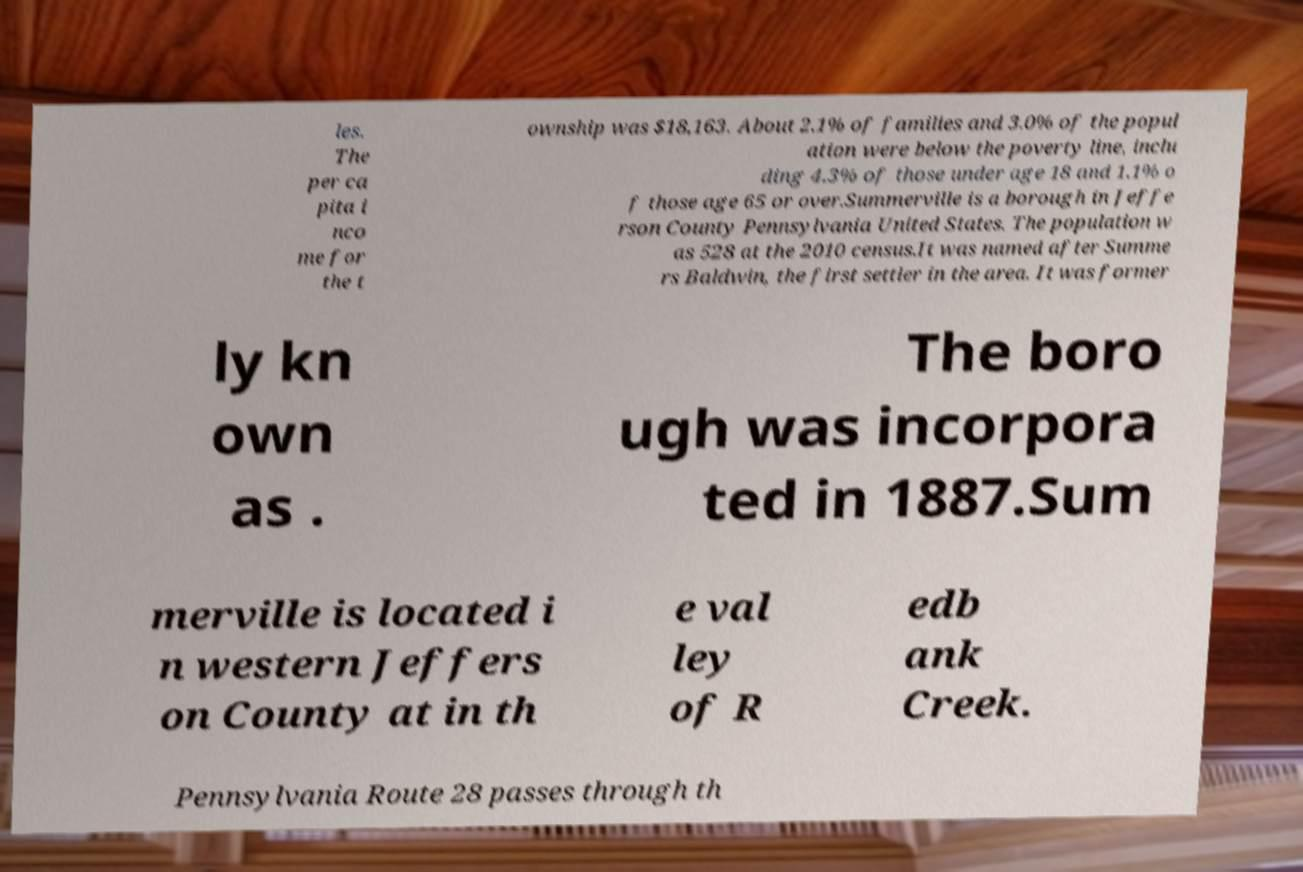There's text embedded in this image that I need extracted. Can you transcribe it verbatim? les. The per ca pita i nco me for the t ownship was $18,163. About 2.1% of families and 3.0% of the popul ation were below the poverty line, inclu ding 4.3% of those under age 18 and 1.1% o f those age 65 or over.Summerville is a borough in Jeffe rson County Pennsylvania United States. The population w as 528 at the 2010 census.It was named after Summe rs Baldwin, the first settler in the area. It was former ly kn own as . The boro ugh was incorpora ted in 1887.Sum merville is located i n western Jeffers on County at in th e val ley of R edb ank Creek. Pennsylvania Route 28 passes through th 